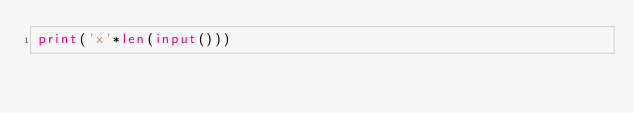Convert code to text. <code><loc_0><loc_0><loc_500><loc_500><_Python_>print('x'*len(input()))</code> 